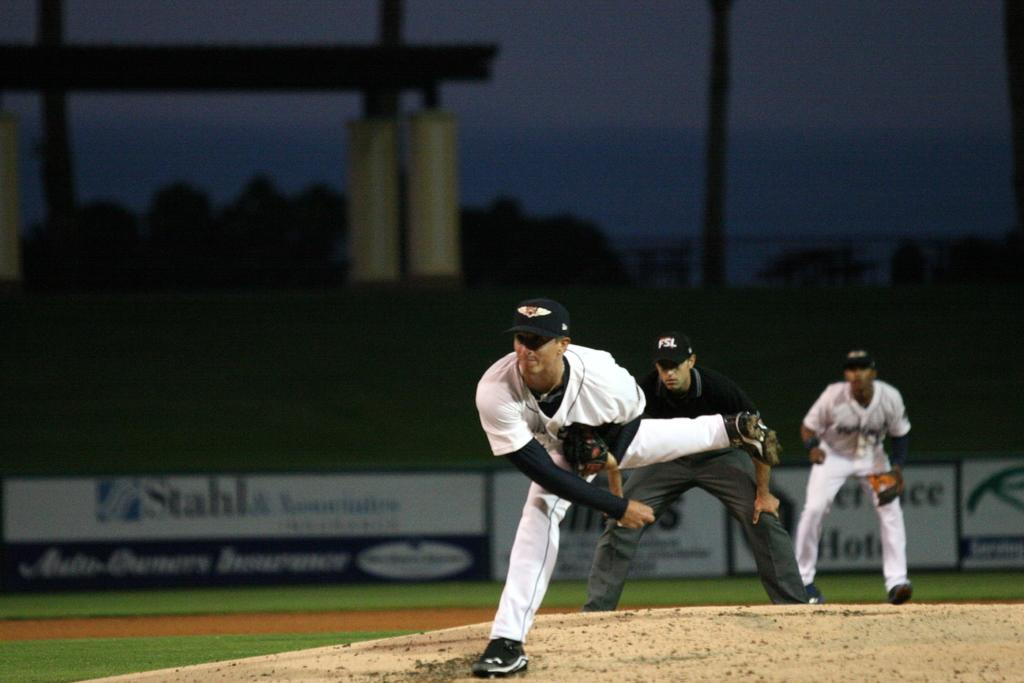<image>
Provide a brief description of the given image. A Stahls ad hangs in the back of this ball park. 